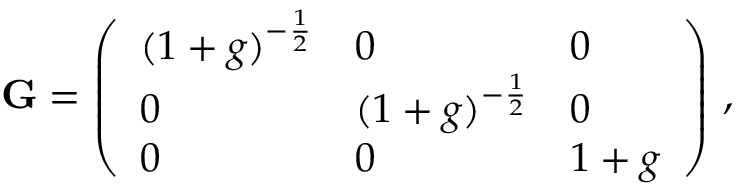Convert formula to latex. <formula><loc_0><loc_0><loc_500><loc_500>G = \left ( \begin{array} { l l l } { ( 1 + g ) ^ { - \frac { 1 } { 2 } } } & { 0 } & { 0 } \\ { 0 } & { ( 1 + g ) ^ { - \frac { 1 } { 2 } } } & { 0 } \\ { 0 } & { 0 } & { 1 + g } \end{array} \right ) \, ,</formula> 